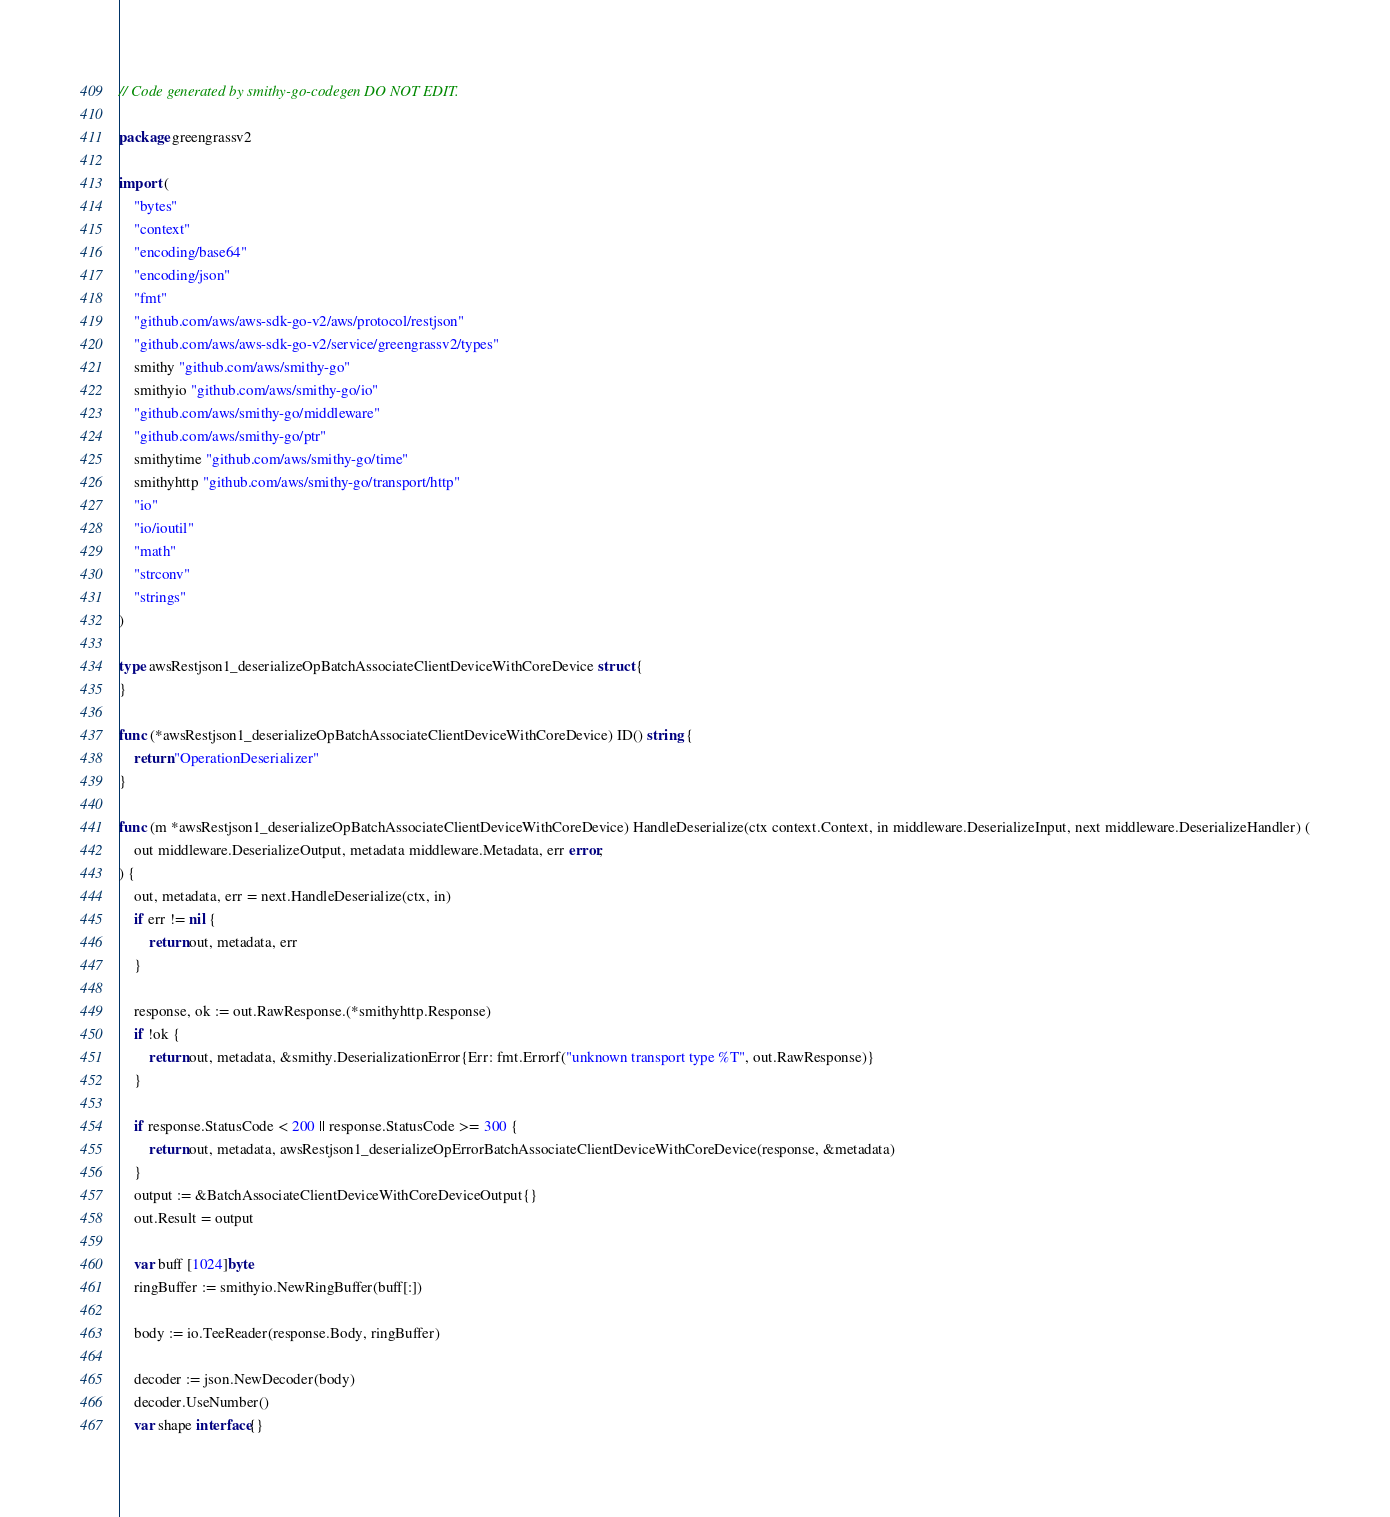<code> <loc_0><loc_0><loc_500><loc_500><_Go_>// Code generated by smithy-go-codegen DO NOT EDIT.

package greengrassv2

import (
	"bytes"
	"context"
	"encoding/base64"
	"encoding/json"
	"fmt"
	"github.com/aws/aws-sdk-go-v2/aws/protocol/restjson"
	"github.com/aws/aws-sdk-go-v2/service/greengrassv2/types"
	smithy "github.com/aws/smithy-go"
	smithyio "github.com/aws/smithy-go/io"
	"github.com/aws/smithy-go/middleware"
	"github.com/aws/smithy-go/ptr"
	smithytime "github.com/aws/smithy-go/time"
	smithyhttp "github.com/aws/smithy-go/transport/http"
	"io"
	"io/ioutil"
	"math"
	"strconv"
	"strings"
)

type awsRestjson1_deserializeOpBatchAssociateClientDeviceWithCoreDevice struct {
}

func (*awsRestjson1_deserializeOpBatchAssociateClientDeviceWithCoreDevice) ID() string {
	return "OperationDeserializer"
}

func (m *awsRestjson1_deserializeOpBatchAssociateClientDeviceWithCoreDevice) HandleDeserialize(ctx context.Context, in middleware.DeserializeInput, next middleware.DeserializeHandler) (
	out middleware.DeserializeOutput, metadata middleware.Metadata, err error,
) {
	out, metadata, err = next.HandleDeserialize(ctx, in)
	if err != nil {
		return out, metadata, err
	}

	response, ok := out.RawResponse.(*smithyhttp.Response)
	if !ok {
		return out, metadata, &smithy.DeserializationError{Err: fmt.Errorf("unknown transport type %T", out.RawResponse)}
	}

	if response.StatusCode < 200 || response.StatusCode >= 300 {
		return out, metadata, awsRestjson1_deserializeOpErrorBatchAssociateClientDeviceWithCoreDevice(response, &metadata)
	}
	output := &BatchAssociateClientDeviceWithCoreDeviceOutput{}
	out.Result = output

	var buff [1024]byte
	ringBuffer := smithyio.NewRingBuffer(buff[:])

	body := io.TeeReader(response.Body, ringBuffer)

	decoder := json.NewDecoder(body)
	decoder.UseNumber()
	var shape interface{}</code> 